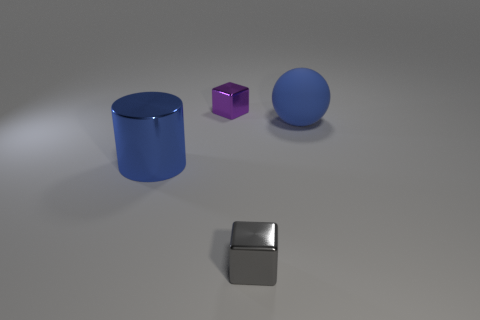Is there any other thing that has the same shape as the small purple shiny object?
Offer a terse response. Yes. There is another thing that is the same shape as the purple metallic object; what is its color?
Make the answer very short. Gray. Do the tiny metallic cube in front of the blue matte object and the tiny object behind the matte object have the same color?
Your response must be concise. No. Are there more large blue matte things on the left side of the big cylinder than big purple rubber balls?
Give a very brief answer. No. How many other objects are there of the same size as the purple metal block?
Give a very brief answer. 1. What number of cubes are on the right side of the purple metallic thing and behind the large metal cylinder?
Offer a very short reply. 0. Are the cube behind the big shiny thing and the big sphere made of the same material?
Ensure brevity in your answer.  No. What is the shape of the shiny object in front of the thing to the left of the small object that is left of the small gray metallic object?
Ensure brevity in your answer.  Cube. Is the number of big rubber things that are left of the tiny purple metallic object the same as the number of blue cylinders in front of the tiny gray metallic block?
Offer a very short reply. Yes. What is the color of the other metallic object that is the same size as the gray metallic object?
Make the answer very short. Purple. 